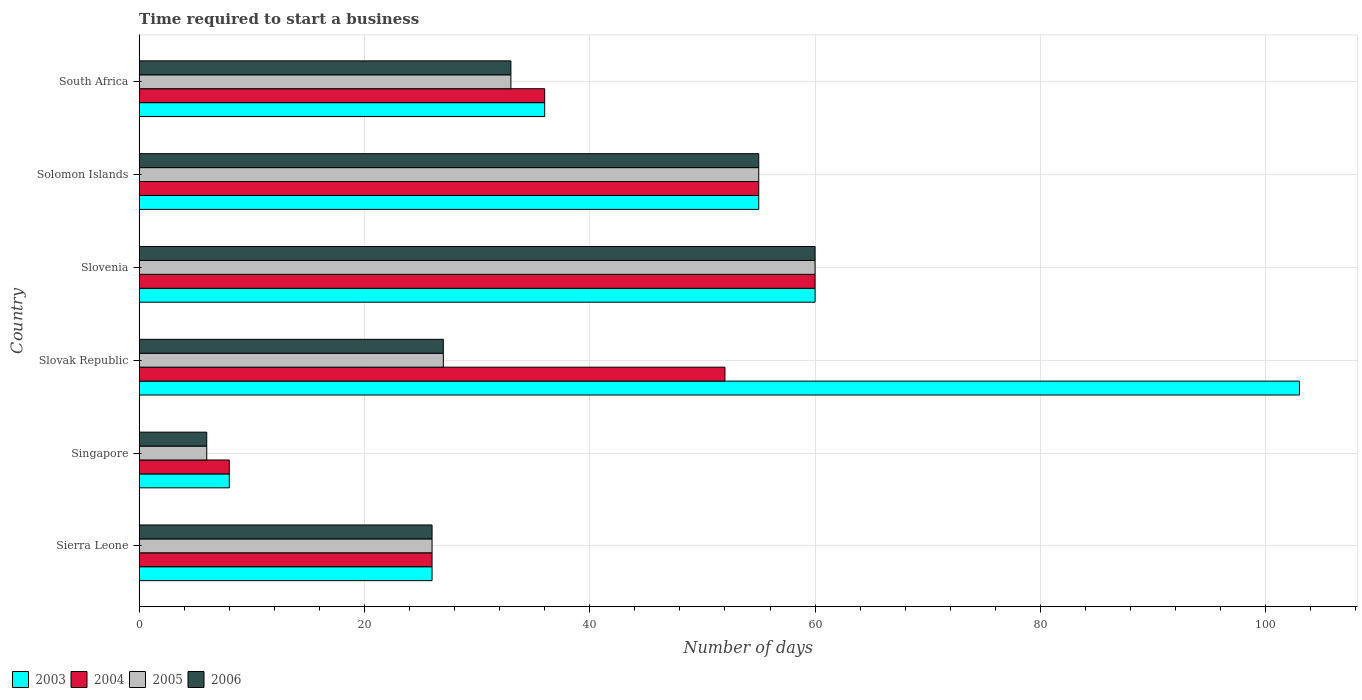How many different coloured bars are there?
Make the answer very short. 4. How many groups of bars are there?
Make the answer very short. 6. Are the number of bars on each tick of the Y-axis equal?
Make the answer very short. Yes. What is the label of the 4th group of bars from the top?
Your response must be concise. Slovak Republic. Across all countries, what is the maximum number of days required to start a business in 2003?
Keep it short and to the point. 103. In which country was the number of days required to start a business in 2004 maximum?
Your response must be concise. Slovenia. In which country was the number of days required to start a business in 2004 minimum?
Your response must be concise. Singapore. What is the total number of days required to start a business in 2004 in the graph?
Your answer should be compact. 237. What is the difference between the number of days required to start a business in 2006 in Singapore and that in Solomon Islands?
Make the answer very short. -49. What is the difference between the number of days required to start a business in 2003 in South Africa and the number of days required to start a business in 2006 in Slovak Republic?
Provide a short and direct response. 9. What is the average number of days required to start a business in 2003 per country?
Keep it short and to the point. 48. In how many countries, is the number of days required to start a business in 2003 greater than 56 days?
Offer a terse response. 2. What is the ratio of the number of days required to start a business in 2003 in Singapore to that in South Africa?
Make the answer very short. 0.22. Is the number of days required to start a business in 2005 in Singapore less than that in Solomon Islands?
Provide a short and direct response. Yes. What is the difference between the highest and the lowest number of days required to start a business in 2005?
Make the answer very short. 54. What does the 2nd bar from the top in Solomon Islands represents?
Give a very brief answer. 2005. How many bars are there?
Give a very brief answer. 24. Are all the bars in the graph horizontal?
Provide a short and direct response. Yes. How many countries are there in the graph?
Offer a terse response. 6. What is the difference between two consecutive major ticks on the X-axis?
Provide a short and direct response. 20. Does the graph contain any zero values?
Keep it short and to the point. No. Where does the legend appear in the graph?
Provide a succinct answer. Bottom left. How many legend labels are there?
Your response must be concise. 4. How are the legend labels stacked?
Your answer should be compact. Horizontal. What is the title of the graph?
Your answer should be compact. Time required to start a business. Does "1967" appear as one of the legend labels in the graph?
Offer a very short reply. No. What is the label or title of the X-axis?
Give a very brief answer. Number of days. What is the label or title of the Y-axis?
Your answer should be very brief. Country. What is the Number of days in 2004 in Sierra Leone?
Your answer should be compact. 26. What is the Number of days of 2003 in Singapore?
Your response must be concise. 8. What is the Number of days in 2004 in Singapore?
Provide a short and direct response. 8. What is the Number of days of 2006 in Singapore?
Give a very brief answer. 6. What is the Number of days of 2003 in Slovak Republic?
Give a very brief answer. 103. What is the Number of days of 2005 in Slovak Republic?
Give a very brief answer. 27. What is the Number of days of 2006 in Slovak Republic?
Give a very brief answer. 27. What is the Number of days in 2003 in Slovenia?
Keep it short and to the point. 60. What is the Number of days of 2005 in Slovenia?
Your response must be concise. 60. What is the Number of days of 2006 in Slovenia?
Make the answer very short. 60. What is the Number of days in 2003 in Solomon Islands?
Your answer should be compact. 55. What is the Number of days of 2004 in Solomon Islands?
Offer a terse response. 55. What is the Number of days of 2005 in Solomon Islands?
Provide a succinct answer. 55. What is the Number of days of 2005 in South Africa?
Your answer should be compact. 33. What is the Number of days in 2006 in South Africa?
Offer a terse response. 33. Across all countries, what is the maximum Number of days in 2003?
Your answer should be compact. 103. Across all countries, what is the maximum Number of days of 2004?
Provide a short and direct response. 60. Across all countries, what is the maximum Number of days in 2005?
Offer a very short reply. 60. Across all countries, what is the maximum Number of days in 2006?
Give a very brief answer. 60. Across all countries, what is the minimum Number of days of 2004?
Your answer should be very brief. 8. What is the total Number of days in 2003 in the graph?
Provide a succinct answer. 288. What is the total Number of days of 2004 in the graph?
Offer a very short reply. 237. What is the total Number of days in 2005 in the graph?
Keep it short and to the point. 207. What is the total Number of days of 2006 in the graph?
Provide a succinct answer. 207. What is the difference between the Number of days of 2005 in Sierra Leone and that in Singapore?
Make the answer very short. 20. What is the difference between the Number of days in 2006 in Sierra Leone and that in Singapore?
Your response must be concise. 20. What is the difference between the Number of days in 2003 in Sierra Leone and that in Slovak Republic?
Make the answer very short. -77. What is the difference between the Number of days of 2003 in Sierra Leone and that in Slovenia?
Offer a terse response. -34. What is the difference between the Number of days of 2004 in Sierra Leone and that in Slovenia?
Your answer should be very brief. -34. What is the difference between the Number of days in 2005 in Sierra Leone and that in Slovenia?
Provide a succinct answer. -34. What is the difference between the Number of days in 2006 in Sierra Leone and that in Slovenia?
Give a very brief answer. -34. What is the difference between the Number of days of 2004 in Sierra Leone and that in Solomon Islands?
Offer a very short reply. -29. What is the difference between the Number of days in 2003 in Sierra Leone and that in South Africa?
Keep it short and to the point. -10. What is the difference between the Number of days in 2004 in Sierra Leone and that in South Africa?
Offer a very short reply. -10. What is the difference between the Number of days in 2003 in Singapore and that in Slovak Republic?
Ensure brevity in your answer.  -95. What is the difference between the Number of days of 2004 in Singapore and that in Slovak Republic?
Your answer should be very brief. -44. What is the difference between the Number of days of 2006 in Singapore and that in Slovak Republic?
Your answer should be compact. -21. What is the difference between the Number of days of 2003 in Singapore and that in Slovenia?
Provide a short and direct response. -52. What is the difference between the Number of days of 2004 in Singapore and that in Slovenia?
Your answer should be very brief. -52. What is the difference between the Number of days in 2005 in Singapore and that in Slovenia?
Provide a succinct answer. -54. What is the difference between the Number of days in 2006 in Singapore and that in Slovenia?
Keep it short and to the point. -54. What is the difference between the Number of days in 2003 in Singapore and that in Solomon Islands?
Give a very brief answer. -47. What is the difference between the Number of days in 2004 in Singapore and that in Solomon Islands?
Give a very brief answer. -47. What is the difference between the Number of days of 2005 in Singapore and that in Solomon Islands?
Ensure brevity in your answer.  -49. What is the difference between the Number of days in 2006 in Singapore and that in Solomon Islands?
Give a very brief answer. -49. What is the difference between the Number of days in 2003 in Singapore and that in South Africa?
Offer a terse response. -28. What is the difference between the Number of days of 2005 in Singapore and that in South Africa?
Your response must be concise. -27. What is the difference between the Number of days in 2005 in Slovak Republic and that in Slovenia?
Ensure brevity in your answer.  -33. What is the difference between the Number of days of 2006 in Slovak Republic and that in Slovenia?
Offer a very short reply. -33. What is the difference between the Number of days in 2004 in Slovak Republic and that in Solomon Islands?
Your response must be concise. -3. What is the difference between the Number of days of 2006 in Slovak Republic and that in Solomon Islands?
Provide a short and direct response. -28. What is the difference between the Number of days in 2005 in Slovak Republic and that in South Africa?
Offer a terse response. -6. What is the difference between the Number of days in 2006 in Slovak Republic and that in South Africa?
Your answer should be compact. -6. What is the difference between the Number of days of 2004 in Slovenia and that in Solomon Islands?
Ensure brevity in your answer.  5. What is the difference between the Number of days of 2005 in Slovenia and that in Solomon Islands?
Offer a terse response. 5. What is the difference between the Number of days in 2004 in Slovenia and that in South Africa?
Make the answer very short. 24. What is the difference between the Number of days in 2005 in Slovenia and that in South Africa?
Make the answer very short. 27. What is the difference between the Number of days in 2006 in Slovenia and that in South Africa?
Keep it short and to the point. 27. What is the difference between the Number of days in 2003 in Solomon Islands and that in South Africa?
Give a very brief answer. 19. What is the difference between the Number of days in 2004 in Solomon Islands and that in South Africa?
Ensure brevity in your answer.  19. What is the difference between the Number of days of 2005 in Solomon Islands and that in South Africa?
Your answer should be very brief. 22. What is the difference between the Number of days of 2006 in Solomon Islands and that in South Africa?
Make the answer very short. 22. What is the difference between the Number of days of 2003 in Sierra Leone and the Number of days of 2005 in Singapore?
Your answer should be compact. 20. What is the difference between the Number of days in 2003 in Sierra Leone and the Number of days in 2006 in Singapore?
Provide a short and direct response. 20. What is the difference between the Number of days in 2004 in Sierra Leone and the Number of days in 2005 in Singapore?
Make the answer very short. 20. What is the difference between the Number of days in 2005 in Sierra Leone and the Number of days in 2006 in Singapore?
Your response must be concise. 20. What is the difference between the Number of days of 2005 in Sierra Leone and the Number of days of 2006 in Slovak Republic?
Provide a short and direct response. -1. What is the difference between the Number of days of 2003 in Sierra Leone and the Number of days of 2004 in Slovenia?
Give a very brief answer. -34. What is the difference between the Number of days of 2003 in Sierra Leone and the Number of days of 2005 in Slovenia?
Offer a very short reply. -34. What is the difference between the Number of days of 2003 in Sierra Leone and the Number of days of 2006 in Slovenia?
Your response must be concise. -34. What is the difference between the Number of days in 2004 in Sierra Leone and the Number of days in 2005 in Slovenia?
Your response must be concise. -34. What is the difference between the Number of days in 2004 in Sierra Leone and the Number of days in 2006 in Slovenia?
Offer a terse response. -34. What is the difference between the Number of days of 2005 in Sierra Leone and the Number of days of 2006 in Slovenia?
Your response must be concise. -34. What is the difference between the Number of days of 2003 in Sierra Leone and the Number of days of 2004 in Solomon Islands?
Ensure brevity in your answer.  -29. What is the difference between the Number of days in 2004 in Sierra Leone and the Number of days in 2006 in Solomon Islands?
Make the answer very short. -29. What is the difference between the Number of days in 2005 in Sierra Leone and the Number of days in 2006 in Solomon Islands?
Your response must be concise. -29. What is the difference between the Number of days of 2003 in Sierra Leone and the Number of days of 2005 in South Africa?
Provide a succinct answer. -7. What is the difference between the Number of days in 2003 in Sierra Leone and the Number of days in 2006 in South Africa?
Provide a succinct answer. -7. What is the difference between the Number of days of 2004 in Sierra Leone and the Number of days of 2005 in South Africa?
Offer a terse response. -7. What is the difference between the Number of days of 2004 in Sierra Leone and the Number of days of 2006 in South Africa?
Ensure brevity in your answer.  -7. What is the difference between the Number of days in 2005 in Sierra Leone and the Number of days in 2006 in South Africa?
Your answer should be compact. -7. What is the difference between the Number of days in 2003 in Singapore and the Number of days in 2004 in Slovak Republic?
Offer a terse response. -44. What is the difference between the Number of days in 2003 in Singapore and the Number of days in 2005 in Slovak Republic?
Make the answer very short. -19. What is the difference between the Number of days of 2004 in Singapore and the Number of days of 2005 in Slovak Republic?
Your answer should be very brief. -19. What is the difference between the Number of days of 2003 in Singapore and the Number of days of 2004 in Slovenia?
Provide a short and direct response. -52. What is the difference between the Number of days of 2003 in Singapore and the Number of days of 2005 in Slovenia?
Provide a short and direct response. -52. What is the difference between the Number of days of 2003 in Singapore and the Number of days of 2006 in Slovenia?
Offer a very short reply. -52. What is the difference between the Number of days of 2004 in Singapore and the Number of days of 2005 in Slovenia?
Your response must be concise. -52. What is the difference between the Number of days in 2004 in Singapore and the Number of days in 2006 in Slovenia?
Make the answer very short. -52. What is the difference between the Number of days in 2005 in Singapore and the Number of days in 2006 in Slovenia?
Offer a terse response. -54. What is the difference between the Number of days in 2003 in Singapore and the Number of days in 2004 in Solomon Islands?
Offer a very short reply. -47. What is the difference between the Number of days in 2003 in Singapore and the Number of days in 2005 in Solomon Islands?
Offer a very short reply. -47. What is the difference between the Number of days of 2003 in Singapore and the Number of days of 2006 in Solomon Islands?
Offer a terse response. -47. What is the difference between the Number of days of 2004 in Singapore and the Number of days of 2005 in Solomon Islands?
Keep it short and to the point. -47. What is the difference between the Number of days in 2004 in Singapore and the Number of days in 2006 in Solomon Islands?
Provide a short and direct response. -47. What is the difference between the Number of days in 2005 in Singapore and the Number of days in 2006 in Solomon Islands?
Ensure brevity in your answer.  -49. What is the difference between the Number of days of 2003 in Singapore and the Number of days of 2006 in South Africa?
Keep it short and to the point. -25. What is the difference between the Number of days in 2004 in Singapore and the Number of days in 2005 in South Africa?
Your response must be concise. -25. What is the difference between the Number of days in 2003 in Slovak Republic and the Number of days in 2004 in Slovenia?
Your response must be concise. 43. What is the difference between the Number of days of 2003 in Slovak Republic and the Number of days of 2006 in Slovenia?
Provide a succinct answer. 43. What is the difference between the Number of days of 2005 in Slovak Republic and the Number of days of 2006 in Slovenia?
Provide a succinct answer. -33. What is the difference between the Number of days of 2003 in Slovak Republic and the Number of days of 2004 in Solomon Islands?
Offer a very short reply. 48. What is the difference between the Number of days of 2003 in Slovak Republic and the Number of days of 2005 in Solomon Islands?
Ensure brevity in your answer.  48. What is the difference between the Number of days in 2003 in Slovak Republic and the Number of days in 2006 in Solomon Islands?
Your answer should be compact. 48. What is the difference between the Number of days of 2003 in Slovak Republic and the Number of days of 2004 in South Africa?
Provide a short and direct response. 67. What is the difference between the Number of days in 2003 in Slovak Republic and the Number of days in 2006 in South Africa?
Provide a short and direct response. 70. What is the difference between the Number of days in 2004 in Slovak Republic and the Number of days in 2006 in South Africa?
Ensure brevity in your answer.  19. What is the difference between the Number of days in 2003 in Slovenia and the Number of days in 2005 in Solomon Islands?
Your answer should be compact. 5. What is the difference between the Number of days in 2003 in Slovenia and the Number of days in 2006 in Solomon Islands?
Provide a short and direct response. 5. What is the difference between the Number of days of 2004 in Slovenia and the Number of days of 2005 in Solomon Islands?
Your response must be concise. 5. What is the difference between the Number of days of 2004 in Slovenia and the Number of days of 2006 in Solomon Islands?
Ensure brevity in your answer.  5. What is the difference between the Number of days in 2005 in Slovenia and the Number of days in 2006 in Solomon Islands?
Your response must be concise. 5. What is the difference between the Number of days in 2003 in Slovenia and the Number of days in 2004 in South Africa?
Offer a terse response. 24. What is the difference between the Number of days of 2003 in Slovenia and the Number of days of 2005 in South Africa?
Ensure brevity in your answer.  27. What is the difference between the Number of days of 2004 in Slovenia and the Number of days of 2005 in South Africa?
Your response must be concise. 27. What is the difference between the Number of days in 2003 in Solomon Islands and the Number of days in 2005 in South Africa?
Offer a very short reply. 22. What is the difference between the Number of days in 2004 in Solomon Islands and the Number of days in 2006 in South Africa?
Your answer should be very brief. 22. What is the difference between the Number of days in 2005 in Solomon Islands and the Number of days in 2006 in South Africa?
Provide a succinct answer. 22. What is the average Number of days in 2003 per country?
Ensure brevity in your answer.  48. What is the average Number of days of 2004 per country?
Keep it short and to the point. 39.5. What is the average Number of days in 2005 per country?
Keep it short and to the point. 34.5. What is the average Number of days in 2006 per country?
Make the answer very short. 34.5. What is the difference between the Number of days of 2003 and Number of days of 2005 in Sierra Leone?
Provide a short and direct response. 0. What is the difference between the Number of days of 2004 and Number of days of 2005 in Sierra Leone?
Offer a terse response. 0. What is the difference between the Number of days in 2004 and Number of days in 2006 in Sierra Leone?
Ensure brevity in your answer.  0. What is the difference between the Number of days in 2005 and Number of days in 2006 in Sierra Leone?
Keep it short and to the point. 0. What is the difference between the Number of days of 2003 and Number of days of 2004 in Singapore?
Your response must be concise. 0. What is the difference between the Number of days of 2003 and Number of days of 2006 in Singapore?
Keep it short and to the point. 2. What is the difference between the Number of days of 2004 and Number of days of 2005 in Singapore?
Your answer should be compact. 2. What is the difference between the Number of days in 2004 and Number of days in 2006 in Singapore?
Keep it short and to the point. 2. What is the difference between the Number of days in 2003 and Number of days in 2004 in Slovak Republic?
Keep it short and to the point. 51. What is the difference between the Number of days in 2003 and Number of days in 2005 in Slovak Republic?
Your answer should be compact. 76. What is the difference between the Number of days in 2003 and Number of days in 2006 in Slovak Republic?
Your response must be concise. 76. What is the difference between the Number of days in 2004 and Number of days in 2005 in Slovak Republic?
Ensure brevity in your answer.  25. What is the difference between the Number of days of 2004 and Number of days of 2006 in Slovak Republic?
Your answer should be compact. 25. What is the difference between the Number of days in 2005 and Number of days in 2006 in Slovak Republic?
Offer a terse response. 0. What is the difference between the Number of days in 2003 and Number of days in 2004 in Slovenia?
Offer a very short reply. 0. What is the difference between the Number of days of 2004 and Number of days of 2005 in Slovenia?
Offer a very short reply. 0. What is the difference between the Number of days in 2004 and Number of days in 2006 in Slovenia?
Offer a terse response. 0. What is the difference between the Number of days of 2003 and Number of days of 2004 in Solomon Islands?
Keep it short and to the point. 0. What is the difference between the Number of days in 2003 and Number of days in 2006 in Solomon Islands?
Provide a short and direct response. 0. What is the difference between the Number of days of 2004 and Number of days of 2006 in Solomon Islands?
Give a very brief answer. 0. What is the difference between the Number of days in 2003 and Number of days in 2004 in South Africa?
Your answer should be very brief. 0. What is the difference between the Number of days in 2003 and Number of days in 2006 in South Africa?
Keep it short and to the point. 3. What is the difference between the Number of days of 2005 and Number of days of 2006 in South Africa?
Ensure brevity in your answer.  0. What is the ratio of the Number of days in 2004 in Sierra Leone to that in Singapore?
Give a very brief answer. 3.25. What is the ratio of the Number of days of 2005 in Sierra Leone to that in Singapore?
Your answer should be very brief. 4.33. What is the ratio of the Number of days of 2006 in Sierra Leone to that in Singapore?
Provide a succinct answer. 4.33. What is the ratio of the Number of days of 2003 in Sierra Leone to that in Slovak Republic?
Your answer should be compact. 0.25. What is the ratio of the Number of days in 2006 in Sierra Leone to that in Slovak Republic?
Make the answer very short. 0.96. What is the ratio of the Number of days of 2003 in Sierra Leone to that in Slovenia?
Your answer should be very brief. 0.43. What is the ratio of the Number of days in 2004 in Sierra Leone to that in Slovenia?
Provide a short and direct response. 0.43. What is the ratio of the Number of days in 2005 in Sierra Leone to that in Slovenia?
Your response must be concise. 0.43. What is the ratio of the Number of days in 2006 in Sierra Leone to that in Slovenia?
Your response must be concise. 0.43. What is the ratio of the Number of days of 2003 in Sierra Leone to that in Solomon Islands?
Provide a succinct answer. 0.47. What is the ratio of the Number of days in 2004 in Sierra Leone to that in Solomon Islands?
Offer a very short reply. 0.47. What is the ratio of the Number of days of 2005 in Sierra Leone to that in Solomon Islands?
Give a very brief answer. 0.47. What is the ratio of the Number of days of 2006 in Sierra Leone to that in Solomon Islands?
Offer a very short reply. 0.47. What is the ratio of the Number of days of 2003 in Sierra Leone to that in South Africa?
Offer a very short reply. 0.72. What is the ratio of the Number of days in 2004 in Sierra Leone to that in South Africa?
Your response must be concise. 0.72. What is the ratio of the Number of days in 2005 in Sierra Leone to that in South Africa?
Offer a very short reply. 0.79. What is the ratio of the Number of days in 2006 in Sierra Leone to that in South Africa?
Ensure brevity in your answer.  0.79. What is the ratio of the Number of days in 2003 in Singapore to that in Slovak Republic?
Offer a very short reply. 0.08. What is the ratio of the Number of days of 2004 in Singapore to that in Slovak Republic?
Ensure brevity in your answer.  0.15. What is the ratio of the Number of days of 2005 in Singapore to that in Slovak Republic?
Ensure brevity in your answer.  0.22. What is the ratio of the Number of days of 2006 in Singapore to that in Slovak Republic?
Ensure brevity in your answer.  0.22. What is the ratio of the Number of days in 2003 in Singapore to that in Slovenia?
Give a very brief answer. 0.13. What is the ratio of the Number of days in 2004 in Singapore to that in Slovenia?
Keep it short and to the point. 0.13. What is the ratio of the Number of days in 2005 in Singapore to that in Slovenia?
Make the answer very short. 0.1. What is the ratio of the Number of days in 2006 in Singapore to that in Slovenia?
Offer a very short reply. 0.1. What is the ratio of the Number of days of 2003 in Singapore to that in Solomon Islands?
Your answer should be very brief. 0.15. What is the ratio of the Number of days of 2004 in Singapore to that in Solomon Islands?
Ensure brevity in your answer.  0.15. What is the ratio of the Number of days of 2005 in Singapore to that in Solomon Islands?
Your response must be concise. 0.11. What is the ratio of the Number of days in 2006 in Singapore to that in Solomon Islands?
Offer a terse response. 0.11. What is the ratio of the Number of days of 2003 in Singapore to that in South Africa?
Your response must be concise. 0.22. What is the ratio of the Number of days of 2004 in Singapore to that in South Africa?
Keep it short and to the point. 0.22. What is the ratio of the Number of days in 2005 in Singapore to that in South Africa?
Offer a terse response. 0.18. What is the ratio of the Number of days in 2006 in Singapore to that in South Africa?
Your answer should be very brief. 0.18. What is the ratio of the Number of days in 2003 in Slovak Republic to that in Slovenia?
Give a very brief answer. 1.72. What is the ratio of the Number of days in 2004 in Slovak Republic to that in Slovenia?
Offer a very short reply. 0.87. What is the ratio of the Number of days in 2005 in Slovak Republic to that in Slovenia?
Your answer should be compact. 0.45. What is the ratio of the Number of days of 2006 in Slovak Republic to that in Slovenia?
Offer a very short reply. 0.45. What is the ratio of the Number of days of 2003 in Slovak Republic to that in Solomon Islands?
Ensure brevity in your answer.  1.87. What is the ratio of the Number of days of 2004 in Slovak Republic to that in Solomon Islands?
Keep it short and to the point. 0.95. What is the ratio of the Number of days in 2005 in Slovak Republic to that in Solomon Islands?
Provide a succinct answer. 0.49. What is the ratio of the Number of days in 2006 in Slovak Republic to that in Solomon Islands?
Keep it short and to the point. 0.49. What is the ratio of the Number of days in 2003 in Slovak Republic to that in South Africa?
Your response must be concise. 2.86. What is the ratio of the Number of days of 2004 in Slovak Republic to that in South Africa?
Ensure brevity in your answer.  1.44. What is the ratio of the Number of days in 2005 in Slovak Republic to that in South Africa?
Your answer should be compact. 0.82. What is the ratio of the Number of days in 2006 in Slovak Republic to that in South Africa?
Your answer should be compact. 0.82. What is the ratio of the Number of days of 2003 in Slovenia to that in Solomon Islands?
Give a very brief answer. 1.09. What is the ratio of the Number of days of 2004 in Slovenia to that in Solomon Islands?
Ensure brevity in your answer.  1.09. What is the ratio of the Number of days of 2005 in Slovenia to that in Solomon Islands?
Ensure brevity in your answer.  1.09. What is the ratio of the Number of days of 2006 in Slovenia to that in Solomon Islands?
Make the answer very short. 1.09. What is the ratio of the Number of days in 2005 in Slovenia to that in South Africa?
Your response must be concise. 1.82. What is the ratio of the Number of days in 2006 in Slovenia to that in South Africa?
Offer a terse response. 1.82. What is the ratio of the Number of days in 2003 in Solomon Islands to that in South Africa?
Your answer should be compact. 1.53. What is the ratio of the Number of days in 2004 in Solomon Islands to that in South Africa?
Make the answer very short. 1.53. What is the difference between the highest and the second highest Number of days of 2003?
Provide a short and direct response. 43. What is the difference between the highest and the second highest Number of days in 2004?
Give a very brief answer. 5. What is the difference between the highest and the second highest Number of days of 2005?
Give a very brief answer. 5. What is the difference between the highest and the second highest Number of days of 2006?
Give a very brief answer. 5. What is the difference between the highest and the lowest Number of days in 2006?
Your answer should be very brief. 54. 